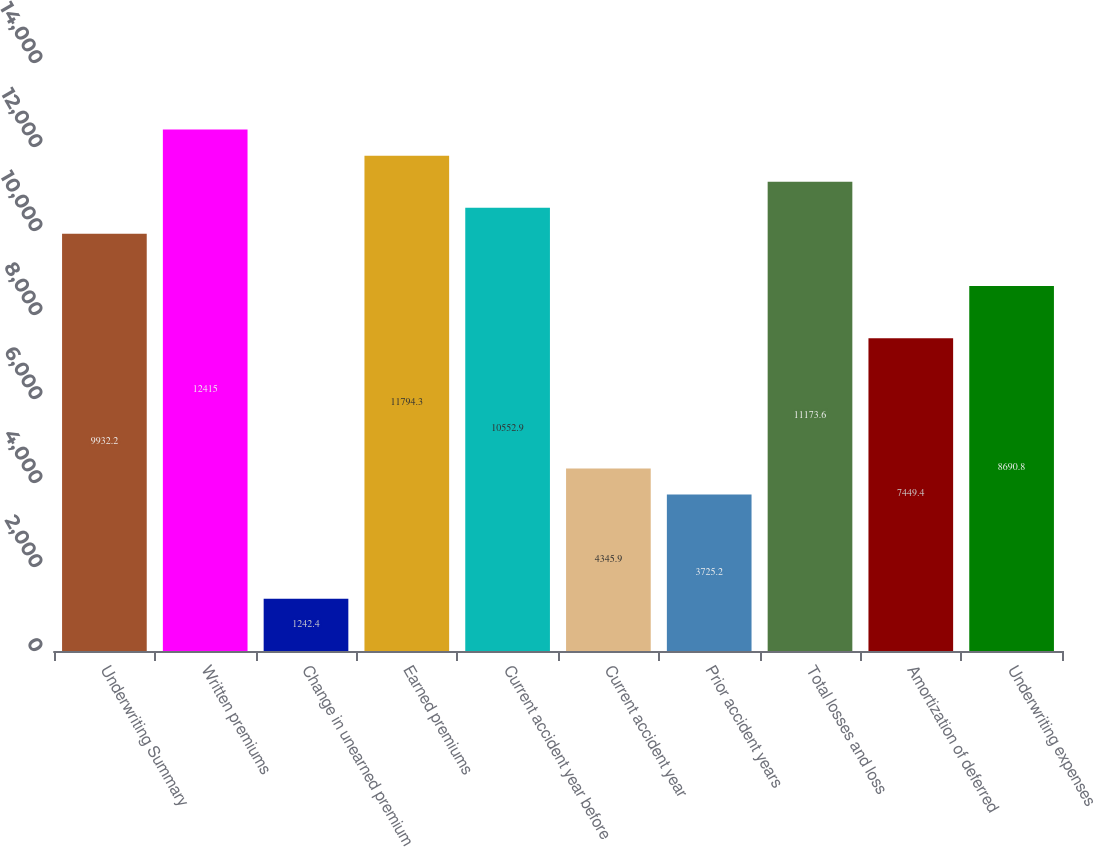<chart> <loc_0><loc_0><loc_500><loc_500><bar_chart><fcel>Underwriting Summary<fcel>Written premiums<fcel>Change in unearned premium<fcel>Earned premiums<fcel>Current accident year before<fcel>Current accident year<fcel>Prior accident years<fcel>Total losses and loss<fcel>Amortization of deferred<fcel>Underwriting expenses<nl><fcel>9932.2<fcel>12415<fcel>1242.4<fcel>11794.3<fcel>10552.9<fcel>4345.9<fcel>3725.2<fcel>11173.6<fcel>7449.4<fcel>8690.8<nl></chart> 